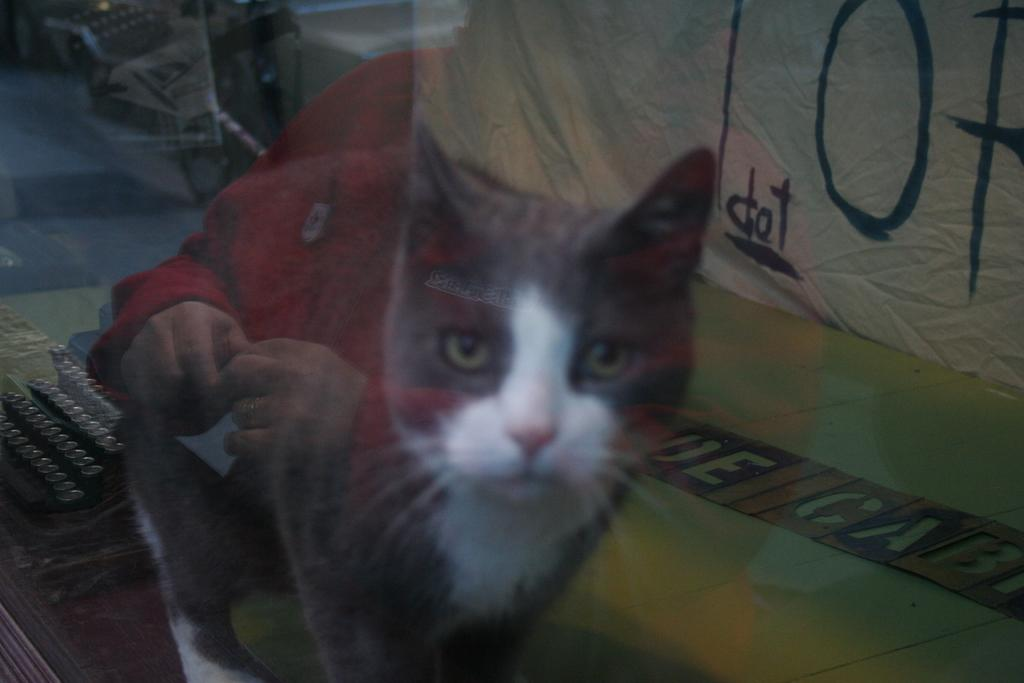What is in the image that can be used to hold liquids? There is a glass in the image. What can be seen through the glass? A cat, a person, a banner, and other objects are visible through the glass. Can you describe the objects visible through the glass? The cat, person, and banner are visible through the glass, along with other unspecified objects. What type of brake is visible through the glass in the image? There is no brake visible through the glass in the image. Who is the writer of the banner visible through the glass? The facts provided do not give any information about the writer of the banner visible through the glass. 